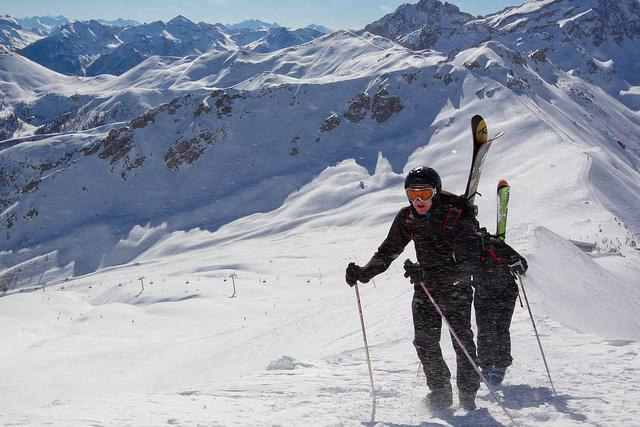What is the primary color of the skis carried on the back of the man following the man? green 